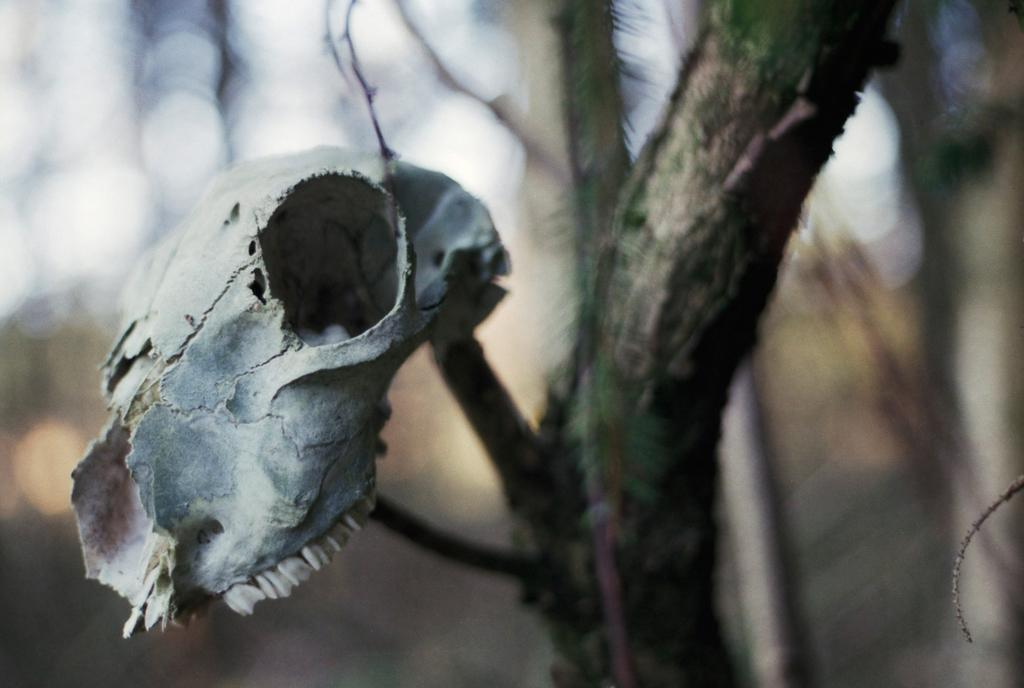What is the main subject of the image? The main subject of the image is a skull of an animal. Where is the skull located in the image? The skull is on a tree in the image. Can you describe the position of the skull in the image? The skull is in the middle of the image. What type of beds can be seen in the image? There are no beds present in the image; it features a skull on a tree. What year is depicted in the image? The image does not depict a specific year; it is a photograph of a skull on a tree. 